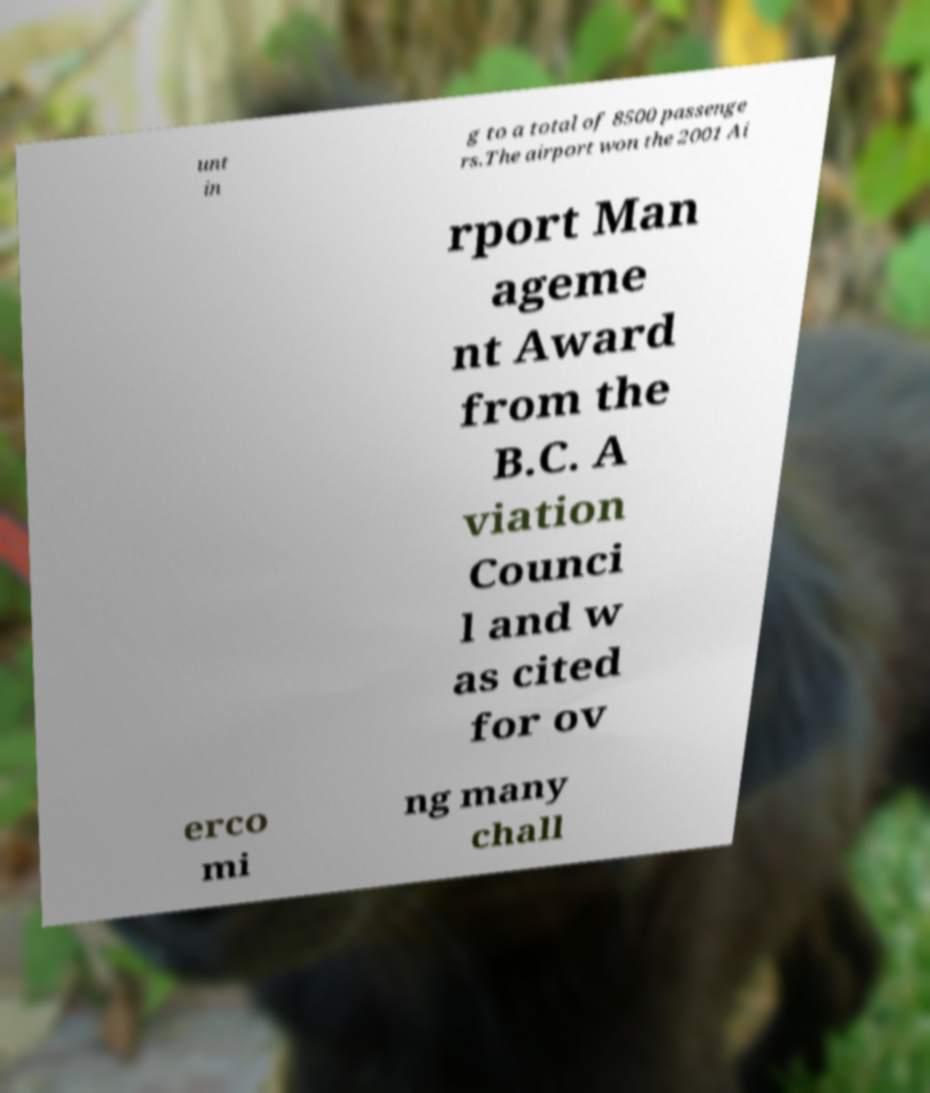Please read and relay the text visible in this image. What does it say? unt in g to a total of 8500 passenge rs.The airport won the 2001 Ai rport Man ageme nt Award from the B.C. A viation Counci l and w as cited for ov erco mi ng many chall 